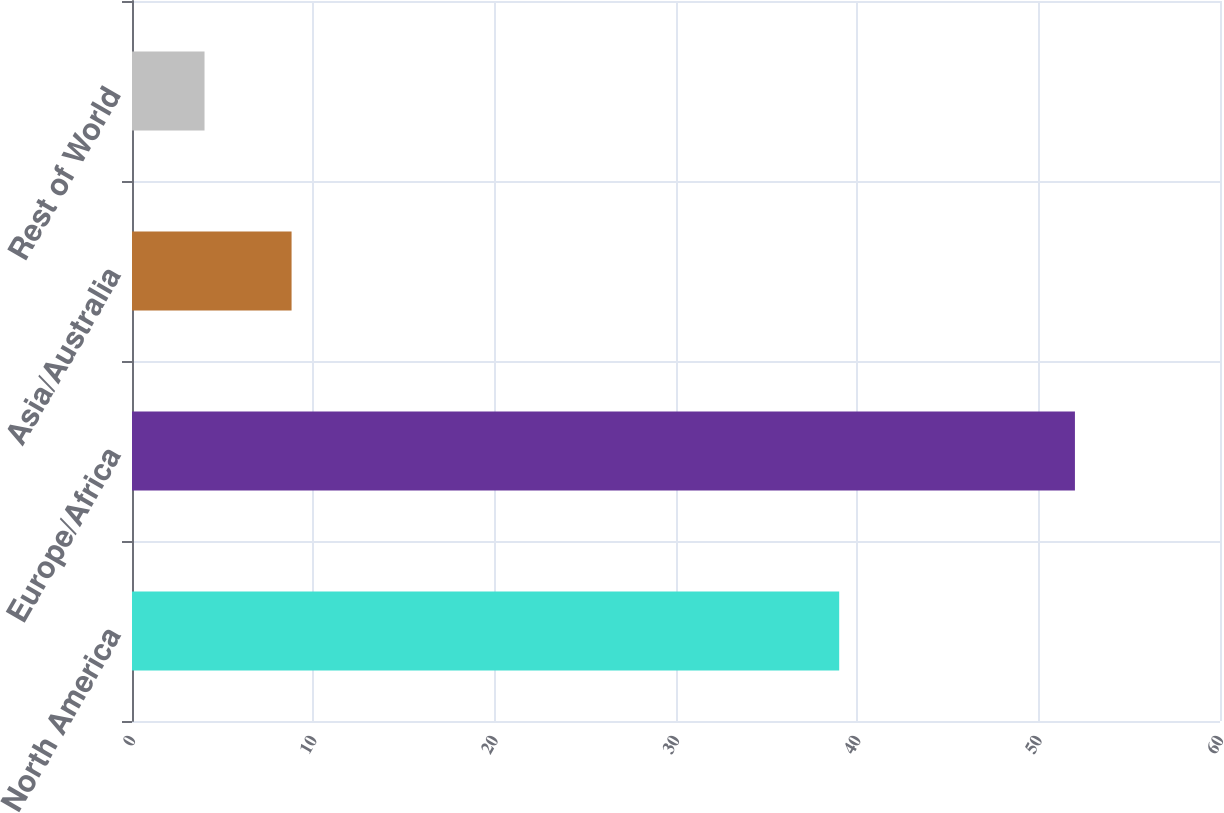Convert chart to OTSL. <chart><loc_0><loc_0><loc_500><loc_500><bar_chart><fcel>North America<fcel>Europe/Africa<fcel>Asia/Australia<fcel>Rest of World<nl><fcel>39<fcel>52<fcel>8.8<fcel>4<nl></chart> 